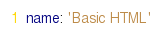<code> <loc_0><loc_0><loc_500><loc_500><_YAML_>name: 'Basic HTML'
</code> 